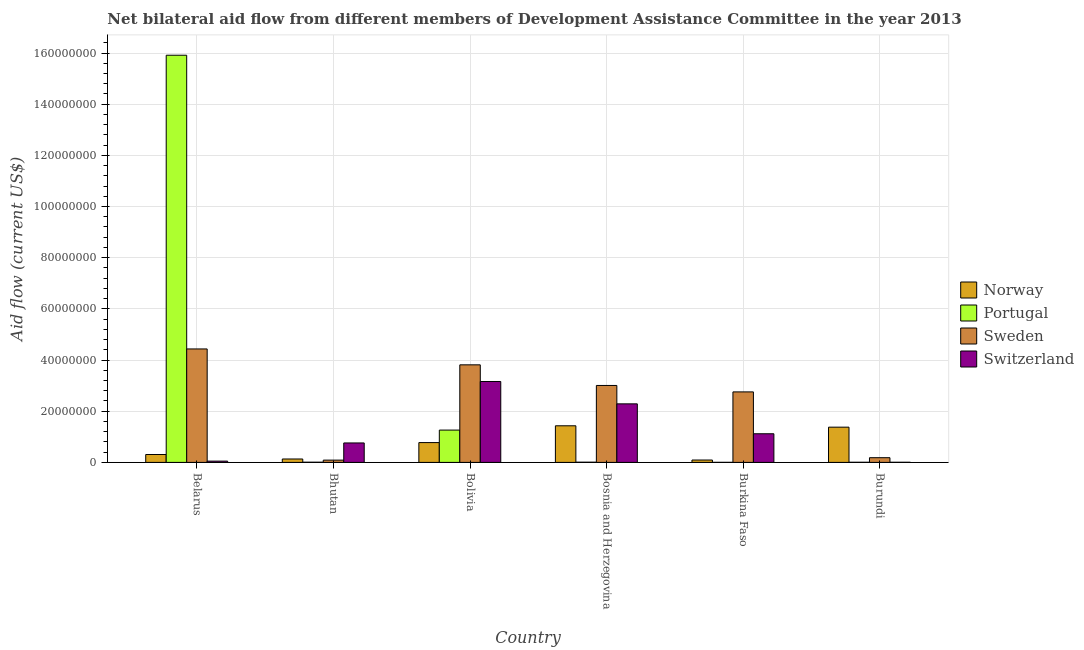How many different coloured bars are there?
Ensure brevity in your answer.  4. Are the number of bars on each tick of the X-axis equal?
Provide a succinct answer. Yes. What is the label of the 2nd group of bars from the left?
Your response must be concise. Bhutan. In how many cases, is the number of bars for a given country not equal to the number of legend labels?
Offer a very short reply. 0. What is the amount of aid given by norway in Burundi?
Make the answer very short. 1.38e+07. Across all countries, what is the maximum amount of aid given by norway?
Your answer should be very brief. 1.43e+07. Across all countries, what is the minimum amount of aid given by switzerland?
Keep it short and to the point. 5.00e+04. In which country was the amount of aid given by switzerland maximum?
Keep it short and to the point. Bolivia. In which country was the amount of aid given by portugal minimum?
Offer a very short reply. Burkina Faso. What is the total amount of aid given by norway in the graph?
Make the answer very short. 4.12e+07. What is the difference between the amount of aid given by norway in Bolivia and that in Burkina Faso?
Your response must be concise. 6.81e+06. What is the difference between the amount of aid given by switzerland in Bolivia and the amount of aid given by norway in Burundi?
Offer a very short reply. 1.78e+07. What is the average amount of aid given by norway per country?
Your answer should be very brief. 6.86e+06. What is the difference between the amount of aid given by switzerland and amount of aid given by portugal in Belarus?
Provide a succinct answer. -1.59e+08. In how many countries, is the amount of aid given by switzerland greater than 32000000 US$?
Make the answer very short. 0. What is the ratio of the amount of aid given by switzerland in Bosnia and Herzegovina to that in Burkina Faso?
Ensure brevity in your answer.  2.04. Is the difference between the amount of aid given by norway in Bhutan and Bosnia and Herzegovina greater than the difference between the amount of aid given by switzerland in Bhutan and Bosnia and Herzegovina?
Give a very brief answer. Yes. What is the difference between the highest and the second highest amount of aid given by norway?
Provide a succinct answer. 5.40e+05. What is the difference between the highest and the lowest amount of aid given by norway?
Ensure brevity in your answer.  1.34e+07. Is it the case that in every country, the sum of the amount of aid given by norway and amount of aid given by switzerland is greater than the sum of amount of aid given by portugal and amount of aid given by sweden?
Keep it short and to the point. No. What does the 3rd bar from the left in Burkina Faso represents?
Give a very brief answer. Sweden. What does the 1st bar from the right in Bolivia represents?
Give a very brief answer. Switzerland. How many bars are there?
Provide a succinct answer. 24. How many countries are there in the graph?
Give a very brief answer. 6. Are the values on the major ticks of Y-axis written in scientific E-notation?
Ensure brevity in your answer.  No. Does the graph contain grids?
Provide a short and direct response. Yes. Where does the legend appear in the graph?
Your response must be concise. Center right. What is the title of the graph?
Offer a terse response. Net bilateral aid flow from different members of Development Assistance Committee in the year 2013. Does "Third 20% of population" appear as one of the legend labels in the graph?
Ensure brevity in your answer.  No. What is the label or title of the X-axis?
Give a very brief answer. Country. What is the Aid flow (current US$) of Norway in Belarus?
Offer a terse response. 3.08e+06. What is the Aid flow (current US$) of Portugal in Belarus?
Offer a very short reply. 1.59e+08. What is the Aid flow (current US$) of Sweden in Belarus?
Give a very brief answer. 4.43e+07. What is the Aid flow (current US$) in Norway in Bhutan?
Offer a terse response. 1.33e+06. What is the Aid flow (current US$) of Sweden in Bhutan?
Your response must be concise. 8.90e+05. What is the Aid flow (current US$) of Switzerland in Bhutan?
Make the answer very short. 7.60e+06. What is the Aid flow (current US$) of Norway in Bolivia?
Your response must be concise. 7.74e+06. What is the Aid flow (current US$) of Portugal in Bolivia?
Keep it short and to the point. 1.26e+07. What is the Aid flow (current US$) in Sweden in Bolivia?
Offer a very short reply. 3.81e+07. What is the Aid flow (current US$) of Switzerland in Bolivia?
Your response must be concise. 3.16e+07. What is the Aid flow (current US$) in Norway in Bosnia and Herzegovina?
Provide a short and direct response. 1.43e+07. What is the Aid flow (current US$) in Portugal in Bosnia and Herzegovina?
Your answer should be compact. 8.00e+04. What is the Aid flow (current US$) of Sweden in Bosnia and Herzegovina?
Keep it short and to the point. 3.01e+07. What is the Aid flow (current US$) of Switzerland in Bosnia and Herzegovina?
Ensure brevity in your answer.  2.29e+07. What is the Aid flow (current US$) of Norway in Burkina Faso?
Offer a terse response. 9.30e+05. What is the Aid flow (current US$) in Portugal in Burkina Faso?
Your answer should be very brief. 2.00e+04. What is the Aid flow (current US$) of Sweden in Burkina Faso?
Offer a terse response. 2.76e+07. What is the Aid flow (current US$) of Switzerland in Burkina Faso?
Your answer should be compact. 1.12e+07. What is the Aid flow (current US$) in Norway in Burundi?
Provide a succinct answer. 1.38e+07. What is the Aid flow (current US$) of Sweden in Burundi?
Provide a short and direct response. 1.84e+06. Across all countries, what is the maximum Aid flow (current US$) of Norway?
Give a very brief answer. 1.43e+07. Across all countries, what is the maximum Aid flow (current US$) in Portugal?
Give a very brief answer. 1.59e+08. Across all countries, what is the maximum Aid flow (current US$) in Sweden?
Your response must be concise. 4.43e+07. Across all countries, what is the maximum Aid flow (current US$) in Switzerland?
Offer a terse response. 3.16e+07. Across all countries, what is the minimum Aid flow (current US$) in Norway?
Offer a very short reply. 9.30e+05. Across all countries, what is the minimum Aid flow (current US$) of Sweden?
Provide a succinct answer. 8.90e+05. What is the total Aid flow (current US$) in Norway in the graph?
Your response must be concise. 4.12e+07. What is the total Aid flow (current US$) of Portugal in the graph?
Offer a terse response. 1.72e+08. What is the total Aid flow (current US$) in Sweden in the graph?
Your answer should be very brief. 1.43e+08. What is the total Aid flow (current US$) in Switzerland in the graph?
Your answer should be compact. 7.38e+07. What is the difference between the Aid flow (current US$) of Norway in Belarus and that in Bhutan?
Your answer should be very brief. 1.75e+06. What is the difference between the Aid flow (current US$) in Portugal in Belarus and that in Bhutan?
Your answer should be compact. 1.59e+08. What is the difference between the Aid flow (current US$) in Sweden in Belarus and that in Bhutan?
Give a very brief answer. 4.34e+07. What is the difference between the Aid flow (current US$) in Switzerland in Belarus and that in Bhutan?
Ensure brevity in your answer.  -7.10e+06. What is the difference between the Aid flow (current US$) in Norway in Belarus and that in Bolivia?
Offer a terse response. -4.66e+06. What is the difference between the Aid flow (current US$) in Portugal in Belarus and that in Bolivia?
Provide a succinct answer. 1.46e+08. What is the difference between the Aid flow (current US$) of Sweden in Belarus and that in Bolivia?
Provide a succinct answer. 6.21e+06. What is the difference between the Aid flow (current US$) in Switzerland in Belarus and that in Bolivia?
Your response must be concise. -3.11e+07. What is the difference between the Aid flow (current US$) of Norway in Belarus and that in Bosnia and Herzegovina?
Make the answer very short. -1.12e+07. What is the difference between the Aid flow (current US$) of Portugal in Belarus and that in Bosnia and Herzegovina?
Offer a terse response. 1.59e+08. What is the difference between the Aid flow (current US$) of Sweden in Belarus and that in Bosnia and Herzegovina?
Your answer should be compact. 1.43e+07. What is the difference between the Aid flow (current US$) of Switzerland in Belarus and that in Bosnia and Herzegovina?
Provide a succinct answer. -2.24e+07. What is the difference between the Aid flow (current US$) in Norway in Belarus and that in Burkina Faso?
Your answer should be very brief. 2.15e+06. What is the difference between the Aid flow (current US$) of Portugal in Belarus and that in Burkina Faso?
Provide a short and direct response. 1.59e+08. What is the difference between the Aid flow (current US$) of Sweden in Belarus and that in Burkina Faso?
Offer a terse response. 1.68e+07. What is the difference between the Aid flow (current US$) in Switzerland in Belarus and that in Burkina Faso?
Make the answer very short. -1.07e+07. What is the difference between the Aid flow (current US$) in Norway in Belarus and that in Burundi?
Your answer should be very brief. -1.07e+07. What is the difference between the Aid flow (current US$) of Portugal in Belarus and that in Burundi?
Provide a succinct answer. 1.59e+08. What is the difference between the Aid flow (current US$) in Sweden in Belarus and that in Burundi?
Make the answer very short. 4.25e+07. What is the difference between the Aid flow (current US$) in Norway in Bhutan and that in Bolivia?
Offer a very short reply. -6.41e+06. What is the difference between the Aid flow (current US$) of Portugal in Bhutan and that in Bolivia?
Your answer should be compact. -1.26e+07. What is the difference between the Aid flow (current US$) of Sweden in Bhutan and that in Bolivia?
Your answer should be compact. -3.72e+07. What is the difference between the Aid flow (current US$) in Switzerland in Bhutan and that in Bolivia?
Provide a succinct answer. -2.40e+07. What is the difference between the Aid flow (current US$) in Norway in Bhutan and that in Bosnia and Herzegovina?
Ensure brevity in your answer.  -1.30e+07. What is the difference between the Aid flow (current US$) of Portugal in Bhutan and that in Bosnia and Herzegovina?
Provide a succinct answer. -10000. What is the difference between the Aid flow (current US$) in Sweden in Bhutan and that in Bosnia and Herzegovina?
Give a very brief answer. -2.92e+07. What is the difference between the Aid flow (current US$) of Switzerland in Bhutan and that in Bosnia and Herzegovina?
Keep it short and to the point. -1.53e+07. What is the difference between the Aid flow (current US$) of Norway in Bhutan and that in Burkina Faso?
Your response must be concise. 4.00e+05. What is the difference between the Aid flow (current US$) of Sweden in Bhutan and that in Burkina Faso?
Provide a succinct answer. -2.67e+07. What is the difference between the Aid flow (current US$) in Switzerland in Bhutan and that in Burkina Faso?
Your response must be concise. -3.59e+06. What is the difference between the Aid flow (current US$) of Norway in Bhutan and that in Burundi?
Offer a terse response. -1.24e+07. What is the difference between the Aid flow (current US$) of Sweden in Bhutan and that in Burundi?
Offer a terse response. -9.50e+05. What is the difference between the Aid flow (current US$) of Switzerland in Bhutan and that in Burundi?
Your response must be concise. 7.55e+06. What is the difference between the Aid flow (current US$) of Norway in Bolivia and that in Bosnia and Herzegovina?
Your answer should be very brief. -6.57e+06. What is the difference between the Aid flow (current US$) of Portugal in Bolivia and that in Bosnia and Herzegovina?
Your answer should be compact. 1.26e+07. What is the difference between the Aid flow (current US$) in Sweden in Bolivia and that in Bosnia and Herzegovina?
Your answer should be very brief. 8.06e+06. What is the difference between the Aid flow (current US$) of Switzerland in Bolivia and that in Bosnia and Herzegovina?
Give a very brief answer. 8.74e+06. What is the difference between the Aid flow (current US$) of Norway in Bolivia and that in Burkina Faso?
Keep it short and to the point. 6.81e+06. What is the difference between the Aid flow (current US$) of Portugal in Bolivia and that in Burkina Faso?
Offer a very short reply. 1.26e+07. What is the difference between the Aid flow (current US$) in Sweden in Bolivia and that in Burkina Faso?
Offer a very short reply. 1.06e+07. What is the difference between the Aid flow (current US$) in Switzerland in Bolivia and that in Burkina Faso?
Your answer should be compact. 2.04e+07. What is the difference between the Aid flow (current US$) of Norway in Bolivia and that in Burundi?
Provide a succinct answer. -6.03e+06. What is the difference between the Aid flow (current US$) in Portugal in Bolivia and that in Burundi?
Make the answer very short. 1.26e+07. What is the difference between the Aid flow (current US$) in Sweden in Bolivia and that in Burundi?
Your answer should be very brief. 3.63e+07. What is the difference between the Aid flow (current US$) in Switzerland in Bolivia and that in Burundi?
Ensure brevity in your answer.  3.16e+07. What is the difference between the Aid flow (current US$) of Norway in Bosnia and Herzegovina and that in Burkina Faso?
Provide a short and direct response. 1.34e+07. What is the difference between the Aid flow (current US$) of Portugal in Bosnia and Herzegovina and that in Burkina Faso?
Your answer should be very brief. 6.00e+04. What is the difference between the Aid flow (current US$) in Sweden in Bosnia and Herzegovina and that in Burkina Faso?
Ensure brevity in your answer.  2.52e+06. What is the difference between the Aid flow (current US$) of Switzerland in Bosnia and Herzegovina and that in Burkina Faso?
Your response must be concise. 1.17e+07. What is the difference between the Aid flow (current US$) of Norway in Bosnia and Herzegovina and that in Burundi?
Offer a very short reply. 5.40e+05. What is the difference between the Aid flow (current US$) of Portugal in Bosnia and Herzegovina and that in Burundi?
Offer a very short reply. 3.00e+04. What is the difference between the Aid flow (current US$) of Sweden in Bosnia and Herzegovina and that in Burundi?
Your answer should be compact. 2.82e+07. What is the difference between the Aid flow (current US$) of Switzerland in Bosnia and Herzegovina and that in Burundi?
Your answer should be very brief. 2.28e+07. What is the difference between the Aid flow (current US$) of Norway in Burkina Faso and that in Burundi?
Your answer should be very brief. -1.28e+07. What is the difference between the Aid flow (current US$) in Sweden in Burkina Faso and that in Burundi?
Provide a short and direct response. 2.57e+07. What is the difference between the Aid flow (current US$) in Switzerland in Burkina Faso and that in Burundi?
Make the answer very short. 1.11e+07. What is the difference between the Aid flow (current US$) of Norway in Belarus and the Aid flow (current US$) of Portugal in Bhutan?
Ensure brevity in your answer.  3.01e+06. What is the difference between the Aid flow (current US$) of Norway in Belarus and the Aid flow (current US$) of Sweden in Bhutan?
Give a very brief answer. 2.19e+06. What is the difference between the Aid flow (current US$) in Norway in Belarus and the Aid flow (current US$) in Switzerland in Bhutan?
Your answer should be very brief. -4.52e+06. What is the difference between the Aid flow (current US$) in Portugal in Belarus and the Aid flow (current US$) in Sweden in Bhutan?
Offer a very short reply. 1.58e+08. What is the difference between the Aid flow (current US$) of Portugal in Belarus and the Aid flow (current US$) of Switzerland in Bhutan?
Provide a succinct answer. 1.52e+08. What is the difference between the Aid flow (current US$) in Sweden in Belarus and the Aid flow (current US$) in Switzerland in Bhutan?
Offer a terse response. 3.67e+07. What is the difference between the Aid flow (current US$) in Norway in Belarus and the Aid flow (current US$) in Portugal in Bolivia?
Your answer should be very brief. -9.55e+06. What is the difference between the Aid flow (current US$) of Norway in Belarus and the Aid flow (current US$) of Sweden in Bolivia?
Your answer should be very brief. -3.50e+07. What is the difference between the Aid flow (current US$) in Norway in Belarus and the Aid flow (current US$) in Switzerland in Bolivia?
Your answer should be compact. -2.85e+07. What is the difference between the Aid flow (current US$) of Portugal in Belarus and the Aid flow (current US$) of Sweden in Bolivia?
Give a very brief answer. 1.21e+08. What is the difference between the Aid flow (current US$) in Portugal in Belarus and the Aid flow (current US$) in Switzerland in Bolivia?
Give a very brief answer. 1.28e+08. What is the difference between the Aid flow (current US$) in Sweden in Belarus and the Aid flow (current US$) in Switzerland in Bolivia?
Your answer should be very brief. 1.27e+07. What is the difference between the Aid flow (current US$) in Norway in Belarus and the Aid flow (current US$) in Sweden in Bosnia and Herzegovina?
Your answer should be compact. -2.70e+07. What is the difference between the Aid flow (current US$) in Norway in Belarus and the Aid flow (current US$) in Switzerland in Bosnia and Herzegovina?
Your response must be concise. -1.98e+07. What is the difference between the Aid flow (current US$) of Portugal in Belarus and the Aid flow (current US$) of Sweden in Bosnia and Herzegovina?
Ensure brevity in your answer.  1.29e+08. What is the difference between the Aid flow (current US$) in Portugal in Belarus and the Aid flow (current US$) in Switzerland in Bosnia and Herzegovina?
Your response must be concise. 1.36e+08. What is the difference between the Aid flow (current US$) in Sweden in Belarus and the Aid flow (current US$) in Switzerland in Bosnia and Herzegovina?
Ensure brevity in your answer.  2.15e+07. What is the difference between the Aid flow (current US$) in Norway in Belarus and the Aid flow (current US$) in Portugal in Burkina Faso?
Your response must be concise. 3.06e+06. What is the difference between the Aid flow (current US$) in Norway in Belarus and the Aid flow (current US$) in Sweden in Burkina Faso?
Make the answer very short. -2.45e+07. What is the difference between the Aid flow (current US$) of Norway in Belarus and the Aid flow (current US$) of Switzerland in Burkina Faso?
Provide a short and direct response. -8.11e+06. What is the difference between the Aid flow (current US$) of Portugal in Belarus and the Aid flow (current US$) of Sweden in Burkina Faso?
Offer a terse response. 1.32e+08. What is the difference between the Aid flow (current US$) in Portugal in Belarus and the Aid flow (current US$) in Switzerland in Burkina Faso?
Make the answer very short. 1.48e+08. What is the difference between the Aid flow (current US$) in Sweden in Belarus and the Aid flow (current US$) in Switzerland in Burkina Faso?
Offer a very short reply. 3.32e+07. What is the difference between the Aid flow (current US$) in Norway in Belarus and the Aid flow (current US$) in Portugal in Burundi?
Your answer should be compact. 3.03e+06. What is the difference between the Aid flow (current US$) of Norway in Belarus and the Aid flow (current US$) of Sweden in Burundi?
Offer a terse response. 1.24e+06. What is the difference between the Aid flow (current US$) of Norway in Belarus and the Aid flow (current US$) of Switzerland in Burundi?
Your response must be concise. 3.03e+06. What is the difference between the Aid flow (current US$) of Portugal in Belarus and the Aid flow (current US$) of Sweden in Burundi?
Give a very brief answer. 1.57e+08. What is the difference between the Aid flow (current US$) in Portugal in Belarus and the Aid flow (current US$) in Switzerland in Burundi?
Give a very brief answer. 1.59e+08. What is the difference between the Aid flow (current US$) in Sweden in Belarus and the Aid flow (current US$) in Switzerland in Burundi?
Provide a short and direct response. 4.43e+07. What is the difference between the Aid flow (current US$) in Norway in Bhutan and the Aid flow (current US$) in Portugal in Bolivia?
Offer a very short reply. -1.13e+07. What is the difference between the Aid flow (current US$) in Norway in Bhutan and the Aid flow (current US$) in Sweden in Bolivia?
Offer a terse response. -3.68e+07. What is the difference between the Aid flow (current US$) of Norway in Bhutan and the Aid flow (current US$) of Switzerland in Bolivia?
Provide a short and direct response. -3.03e+07. What is the difference between the Aid flow (current US$) of Portugal in Bhutan and the Aid flow (current US$) of Sweden in Bolivia?
Keep it short and to the point. -3.81e+07. What is the difference between the Aid flow (current US$) of Portugal in Bhutan and the Aid flow (current US$) of Switzerland in Bolivia?
Make the answer very short. -3.16e+07. What is the difference between the Aid flow (current US$) of Sweden in Bhutan and the Aid flow (current US$) of Switzerland in Bolivia?
Make the answer very short. -3.07e+07. What is the difference between the Aid flow (current US$) in Norway in Bhutan and the Aid flow (current US$) in Portugal in Bosnia and Herzegovina?
Your answer should be compact. 1.25e+06. What is the difference between the Aid flow (current US$) in Norway in Bhutan and the Aid flow (current US$) in Sweden in Bosnia and Herzegovina?
Ensure brevity in your answer.  -2.87e+07. What is the difference between the Aid flow (current US$) in Norway in Bhutan and the Aid flow (current US$) in Switzerland in Bosnia and Herzegovina?
Offer a terse response. -2.16e+07. What is the difference between the Aid flow (current US$) of Portugal in Bhutan and the Aid flow (current US$) of Sweden in Bosnia and Herzegovina?
Provide a short and direct response. -3.00e+07. What is the difference between the Aid flow (current US$) in Portugal in Bhutan and the Aid flow (current US$) in Switzerland in Bosnia and Herzegovina?
Offer a very short reply. -2.28e+07. What is the difference between the Aid flow (current US$) of Sweden in Bhutan and the Aid flow (current US$) of Switzerland in Bosnia and Herzegovina?
Offer a terse response. -2.20e+07. What is the difference between the Aid flow (current US$) in Norway in Bhutan and the Aid flow (current US$) in Portugal in Burkina Faso?
Provide a succinct answer. 1.31e+06. What is the difference between the Aid flow (current US$) of Norway in Bhutan and the Aid flow (current US$) of Sweden in Burkina Faso?
Offer a terse response. -2.62e+07. What is the difference between the Aid flow (current US$) of Norway in Bhutan and the Aid flow (current US$) of Switzerland in Burkina Faso?
Your answer should be compact. -9.86e+06. What is the difference between the Aid flow (current US$) in Portugal in Bhutan and the Aid flow (current US$) in Sweden in Burkina Faso?
Your response must be concise. -2.75e+07. What is the difference between the Aid flow (current US$) in Portugal in Bhutan and the Aid flow (current US$) in Switzerland in Burkina Faso?
Your answer should be compact. -1.11e+07. What is the difference between the Aid flow (current US$) of Sweden in Bhutan and the Aid flow (current US$) of Switzerland in Burkina Faso?
Your answer should be compact. -1.03e+07. What is the difference between the Aid flow (current US$) of Norway in Bhutan and the Aid flow (current US$) of Portugal in Burundi?
Provide a short and direct response. 1.28e+06. What is the difference between the Aid flow (current US$) in Norway in Bhutan and the Aid flow (current US$) in Sweden in Burundi?
Make the answer very short. -5.10e+05. What is the difference between the Aid flow (current US$) in Norway in Bhutan and the Aid flow (current US$) in Switzerland in Burundi?
Provide a succinct answer. 1.28e+06. What is the difference between the Aid flow (current US$) of Portugal in Bhutan and the Aid flow (current US$) of Sweden in Burundi?
Provide a succinct answer. -1.77e+06. What is the difference between the Aid flow (current US$) of Sweden in Bhutan and the Aid flow (current US$) of Switzerland in Burundi?
Give a very brief answer. 8.40e+05. What is the difference between the Aid flow (current US$) of Norway in Bolivia and the Aid flow (current US$) of Portugal in Bosnia and Herzegovina?
Give a very brief answer. 7.66e+06. What is the difference between the Aid flow (current US$) in Norway in Bolivia and the Aid flow (current US$) in Sweden in Bosnia and Herzegovina?
Provide a short and direct response. -2.23e+07. What is the difference between the Aid flow (current US$) in Norway in Bolivia and the Aid flow (current US$) in Switzerland in Bosnia and Herzegovina?
Make the answer very short. -1.51e+07. What is the difference between the Aid flow (current US$) in Portugal in Bolivia and the Aid flow (current US$) in Sweden in Bosnia and Herzegovina?
Your answer should be compact. -1.74e+07. What is the difference between the Aid flow (current US$) in Portugal in Bolivia and the Aid flow (current US$) in Switzerland in Bosnia and Herzegovina?
Offer a terse response. -1.02e+07. What is the difference between the Aid flow (current US$) in Sweden in Bolivia and the Aid flow (current US$) in Switzerland in Bosnia and Herzegovina?
Your answer should be compact. 1.52e+07. What is the difference between the Aid flow (current US$) in Norway in Bolivia and the Aid flow (current US$) in Portugal in Burkina Faso?
Make the answer very short. 7.72e+06. What is the difference between the Aid flow (current US$) of Norway in Bolivia and the Aid flow (current US$) of Sweden in Burkina Faso?
Provide a succinct answer. -1.98e+07. What is the difference between the Aid flow (current US$) of Norway in Bolivia and the Aid flow (current US$) of Switzerland in Burkina Faso?
Provide a short and direct response. -3.45e+06. What is the difference between the Aid flow (current US$) of Portugal in Bolivia and the Aid flow (current US$) of Sweden in Burkina Faso?
Ensure brevity in your answer.  -1.49e+07. What is the difference between the Aid flow (current US$) in Portugal in Bolivia and the Aid flow (current US$) in Switzerland in Burkina Faso?
Your response must be concise. 1.44e+06. What is the difference between the Aid flow (current US$) in Sweden in Bolivia and the Aid flow (current US$) in Switzerland in Burkina Faso?
Offer a terse response. 2.69e+07. What is the difference between the Aid flow (current US$) of Norway in Bolivia and the Aid flow (current US$) of Portugal in Burundi?
Your response must be concise. 7.69e+06. What is the difference between the Aid flow (current US$) of Norway in Bolivia and the Aid flow (current US$) of Sweden in Burundi?
Your answer should be very brief. 5.90e+06. What is the difference between the Aid flow (current US$) in Norway in Bolivia and the Aid flow (current US$) in Switzerland in Burundi?
Provide a succinct answer. 7.69e+06. What is the difference between the Aid flow (current US$) of Portugal in Bolivia and the Aid flow (current US$) of Sweden in Burundi?
Provide a short and direct response. 1.08e+07. What is the difference between the Aid flow (current US$) in Portugal in Bolivia and the Aid flow (current US$) in Switzerland in Burundi?
Your answer should be very brief. 1.26e+07. What is the difference between the Aid flow (current US$) in Sweden in Bolivia and the Aid flow (current US$) in Switzerland in Burundi?
Offer a terse response. 3.81e+07. What is the difference between the Aid flow (current US$) of Norway in Bosnia and Herzegovina and the Aid flow (current US$) of Portugal in Burkina Faso?
Provide a succinct answer. 1.43e+07. What is the difference between the Aid flow (current US$) of Norway in Bosnia and Herzegovina and the Aid flow (current US$) of Sweden in Burkina Faso?
Provide a succinct answer. -1.32e+07. What is the difference between the Aid flow (current US$) in Norway in Bosnia and Herzegovina and the Aid flow (current US$) in Switzerland in Burkina Faso?
Offer a terse response. 3.12e+06. What is the difference between the Aid flow (current US$) of Portugal in Bosnia and Herzegovina and the Aid flow (current US$) of Sweden in Burkina Faso?
Keep it short and to the point. -2.75e+07. What is the difference between the Aid flow (current US$) of Portugal in Bosnia and Herzegovina and the Aid flow (current US$) of Switzerland in Burkina Faso?
Give a very brief answer. -1.11e+07. What is the difference between the Aid flow (current US$) of Sweden in Bosnia and Herzegovina and the Aid flow (current US$) of Switzerland in Burkina Faso?
Make the answer very short. 1.89e+07. What is the difference between the Aid flow (current US$) of Norway in Bosnia and Herzegovina and the Aid flow (current US$) of Portugal in Burundi?
Ensure brevity in your answer.  1.43e+07. What is the difference between the Aid flow (current US$) in Norway in Bosnia and Herzegovina and the Aid flow (current US$) in Sweden in Burundi?
Make the answer very short. 1.25e+07. What is the difference between the Aid flow (current US$) of Norway in Bosnia and Herzegovina and the Aid flow (current US$) of Switzerland in Burundi?
Make the answer very short. 1.43e+07. What is the difference between the Aid flow (current US$) in Portugal in Bosnia and Herzegovina and the Aid flow (current US$) in Sweden in Burundi?
Make the answer very short. -1.76e+06. What is the difference between the Aid flow (current US$) in Sweden in Bosnia and Herzegovina and the Aid flow (current US$) in Switzerland in Burundi?
Give a very brief answer. 3.00e+07. What is the difference between the Aid flow (current US$) of Norway in Burkina Faso and the Aid flow (current US$) of Portugal in Burundi?
Make the answer very short. 8.80e+05. What is the difference between the Aid flow (current US$) in Norway in Burkina Faso and the Aid flow (current US$) in Sweden in Burundi?
Offer a very short reply. -9.10e+05. What is the difference between the Aid flow (current US$) in Norway in Burkina Faso and the Aid flow (current US$) in Switzerland in Burundi?
Your answer should be very brief. 8.80e+05. What is the difference between the Aid flow (current US$) of Portugal in Burkina Faso and the Aid flow (current US$) of Sweden in Burundi?
Provide a short and direct response. -1.82e+06. What is the difference between the Aid flow (current US$) of Portugal in Burkina Faso and the Aid flow (current US$) of Switzerland in Burundi?
Provide a succinct answer. -3.00e+04. What is the difference between the Aid flow (current US$) in Sweden in Burkina Faso and the Aid flow (current US$) in Switzerland in Burundi?
Your answer should be very brief. 2.75e+07. What is the average Aid flow (current US$) of Norway per country?
Your answer should be very brief. 6.86e+06. What is the average Aid flow (current US$) of Portugal per country?
Ensure brevity in your answer.  2.87e+07. What is the average Aid flow (current US$) in Sweden per country?
Give a very brief answer. 2.38e+07. What is the average Aid flow (current US$) of Switzerland per country?
Provide a succinct answer. 1.23e+07. What is the difference between the Aid flow (current US$) in Norway and Aid flow (current US$) in Portugal in Belarus?
Provide a short and direct response. -1.56e+08. What is the difference between the Aid flow (current US$) in Norway and Aid flow (current US$) in Sweden in Belarus?
Provide a succinct answer. -4.13e+07. What is the difference between the Aid flow (current US$) of Norway and Aid flow (current US$) of Switzerland in Belarus?
Ensure brevity in your answer.  2.58e+06. What is the difference between the Aid flow (current US$) in Portugal and Aid flow (current US$) in Sweden in Belarus?
Offer a very short reply. 1.15e+08. What is the difference between the Aid flow (current US$) of Portugal and Aid flow (current US$) of Switzerland in Belarus?
Provide a succinct answer. 1.59e+08. What is the difference between the Aid flow (current US$) of Sweden and Aid flow (current US$) of Switzerland in Belarus?
Provide a short and direct response. 4.38e+07. What is the difference between the Aid flow (current US$) in Norway and Aid flow (current US$) in Portugal in Bhutan?
Offer a terse response. 1.26e+06. What is the difference between the Aid flow (current US$) of Norway and Aid flow (current US$) of Switzerland in Bhutan?
Offer a very short reply. -6.27e+06. What is the difference between the Aid flow (current US$) in Portugal and Aid flow (current US$) in Sweden in Bhutan?
Your answer should be very brief. -8.20e+05. What is the difference between the Aid flow (current US$) in Portugal and Aid flow (current US$) in Switzerland in Bhutan?
Provide a short and direct response. -7.53e+06. What is the difference between the Aid flow (current US$) of Sweden and Aid flow (current US$) of Switzerland in Bhutan?
Ensure brevity in your answer.  -6.71e+06. What is the difference between the Aid flow (current US$) in Norway and Aid flow (current US$) in Portugal in Bolivia?
Your response must be concise. -4.89e+06. What is the difference between the Aid flow (current US$) of Norway and Aid flow (current US$) of Sweden in Bolivia?
Provide a succinct answer. -3.04e+07. What is the difference between the Aid flow (current US$) of Norway and Aid flow (current US$) of Switzerland in Bolivia?
Provide a succinct answer. -2.39e+07. What is the difference between the Aid flow (current US$) of Portugal and Aid flow (current US$) of Sweden in Bolivia?
Give a very brief answer. -2.55e+07. What is the difference between the Aid flow (current US$) of Portugal and Aid flow (current US$) of Switzerland in Bolivia?
Ensure brevity in your answer.  -1.90e+07. What is the difference between the Aid flow (current US$) of Sweden and Aid flow (current US$) of Switzerland in Bolivia?
Provide a short and direct response. 6.51e+06. What is the difference between the Aid flow (current US$) in Norway and Aid flow (current US$) in Portugal in Bosnia and Herzegovina?
Your response must be concise. 1.42e+07. What is the difference between the Aid flow (current US$) in Norway and Aid flow (current US$) in Sweden in Bosnia and Herzegovina?
Ensure brevity in your answer.  -1.58e+07. What is the difference between the Aid flow (current US$) of Norway and Aid flow (current US$) of Switzerland in Bosnia and Herzegovina?
Give a very brief answer. -8.57e+06. What is the difference between the Aid flow (current US$) in Portugal and Aid flow (current US$) in Sweden in Bosnia and Herzegovina?
Make the answer very short. -3.00e+07. What is the difference between the Aid flow (current US$) in Portugal and Aid flow (current US$) in Switzerland in Bosnia and Herzegovina?
Offer a terse response. -2.28e+07. What is the difference between the Aid flow (current US$) of Sweden and Aid flow (current US$) of Switzerland in Bosnia and Herzegovina?
Your answer should be compact. 7.19e+06. What is the difference between the Aid flow (current US$) in Norway and Aid flow (current US$) in Portugal in Burkina Faso?
Keep it short and to the point. 9.10e+05. What is the difference between the Aid flow (current US$) in Norway and Aid flow (current US$) in Sweden in Burkina Faso?
Give a very brief answer. -2.66e+07. What is the difference between the Aid flow (current US$) of Norway and Aid flow (current US$) of Switzerland in Burkina Faso?
Offer a very short reply. -1.03e+07. What is the difference between the Aid flow (current US$) of Portugal and Aid flow (current US$) of Sweden in Burkina Faso?
Make the answer very short. -2.75e+07. What is the difference between the Aid flow (current US$) in Portugal and Aid flow (current US$) in Switzerland in Burkina Faso?
Your answer should be very brief. -1.12e+07. What is the difference between the Aid flow (current US$) of Sweden and Aid flow (current US$) of Switzerland in Burkina Faso?
Your answer should be compact. 1.64e+07. What is the difference between the Aid flow (current US$) of Norway and Aid flow (current US$) of Portugal in Burundi?
Keep it short and to the point. 1.37e+07. What is the difference between the Aid flow (current US$) of Norway and Aid flow (current US$) of Sweden in Burundi?
Your answer should be compact. 1.19e+07. What is the difference between the Aid flow (current US$) of Norway and Aid flow (current US$) of Switzerland in Burundi?
Your answer should be compact. 1.37e+07. What is the difference between the Aid flow (current US$) in Portugal and Aid flow (current US$) in Sweden in Burundi?
Your response must be concise. -1.79e+06. What is the difference between the Aid flow (current US$) in Sweden and Aid flow (current US$) in Switzerland in Burundi?
Offer a very short reply. 1.79e+06. What is the ratio of the Aid flow (current US$) in Norway in Belarus to that in Bhutan?
Give a very brief answer. 2.32. What is the ratio of the Aid flow (current US$) in Portugal in Belarus to that in Bhutan?
Your response must be concise. 2273.29. What is the ratio of the Aid flow (current US$) of Sweden in Belarus to that in Bhutan?
Provide a succinct answer. 49.82. What is the ratio of the Aid flow (current US$) in Switzerland in Belarus to that in Bhutan?
Ensure brevity in your answer.  0.07. What is the ratio of the Aid flow (current US$) of Norway in Belarus to that in Bolivia?
Offer a very short reply. 0.4. What is the ratio of the Aid flow (current US$) of Portugal in Belarus to that in Bolivia?
Offer a very short reply. 12.6. What is the ratio of the Aid flow (current US$) in Sweden in Belarus to that in Bolivia?
Offer a terse response. 1.16. What is the ratio of the Aid flow (current US$) in Switzerland in Belarus to that in Bolivia?
Keep it short and to the point. 0.02. What is the ratio of the Aid flow (current US$) of Norway in Belarus to that in Bosnia and Herzegovina?
Provide a succinct answer. 0.22. What is the ratio of the Aid flow (current US$) of Portugal in Belarus to that in Bosnia and Herzegovina?
Ensure brevity in your answer.  1989.12. What is the ratio of the Aid flow (current US$) of Sweden in Belarus to that in Bosnia and Herzegovina?
Offer a terse response. 1.47. What is the ratio of the Aid flow (current US$) of Switzerland in Belarus to that in Bosnia and Herzegovina?
Offer a very short reply. 0.02. What is the ratio of the Aid flow (current US$) of Norway in Belarus to that in Burkina Faso?
Your answer should be compact. 3.31. What is the ratio of the Aid flow (current US$) in Portugal in Belarus to that in Burkina Faso?
Your answer should be very brief. 7956.5. What is the ratio of the Aid flow (current US$) of Sweden in Belarus to that in Burkina Faso?
Provide a succinct answer. 1.61. What is the ratio of the Aid flow (current US$) in Switzerland in Belarus to that in Burkina Faso?
Provide a succinct answer. 0.04. What is the ratio of the Aid flow (current US$) of Norway in Belarus to that in Burundi?
Your answer should be very brief. 0.22. What is the ratio of the Aid flow (current US$) in Portugal in Belarus to that in Burundi?
Provide a succinct answer. 3182.6. What is the ratio of the Aid flow (current US$) in Sweden in Belarus to that in Burundi?
Your answer should be compact. 24.1. What is the ratio of the Aid flow (current US$) of Switzerland in Belarus to that in Burundi?
Your response must be concise. 10. What is the ratio of the Aid flow (current US$) in Norway in Bhutan to that in Bolivia?
Make the answer very short. 0.17. What is the ratio of the Aid flow (current US$) of Portugal in Bhutan to that in Bolivia?
Your answer should be very brief. 0.01. What is the ratio of the Aid flow (current US$) of Sweden in Bhutan to that in Bolivia?
Keep it short and to the point. 0.02. What is the ratio of the Aid flow (current US$) in Switzerland in Bhutan to that in Bolivia?
Keep it short and to the point. 0.24. What is the ratio of the Aid flow (current US$) of Norway in Bhutan to that in Bosnia and Herzegovina?
Provide a short and direct response. 0.09. What is the ratio of the Aid flow (current US$) in Sweden in Bhutan to that in Bosnia and Herzegovina?
Offer a terse response. 0.03. What is the ratio of the Aid flow (current US$) of Switzerland in Bhutan to that in Bosnia and Herzegovina?
Keep it short and to the point. 0.33. What is the ratio of the Aid flow (current US$) in Norway in Bhutan to that in Burkina Faso?
Your answer should be compact. 1.43. What is the ratio of the Aid flow (current US$) in Portugal in Bhutan to that in Burkina Faso?
Offer a very short reply. 3.5. What is the ratio of the Aid flow (current US$) in Sweden in Bhutan to that in Burkina Faso?
Give a very brief answer. 0.03. What is the ratio of the Aid flow (current US$) in Switzerland in Bhutan to that in Burkina Faso?
Your answer should be compact. 0.68. What is the ratio of the Aid flow (current US$) of Norway in Bhutan to that in Burundi?
Your response must be concise. 0.1. What is the ratio of the Aid flow (current US$) in Portugal in Bhutan to that in Burundi?
Ensure brevity in your answer.  1.4. What is the ratio of the Aid flow (current US$) in Sweden in Bhutan to that in Burundi?
Your answer should be very brief. 0.48. What is the ratio of the Aid flow (current US$) in Switzerland in Bhutan to that in Burundi?
Keep it short and to the point. 152. What is the ratio of the Aid flow (current US$) in Norway in Bolivia to that in Bosnia and Herzegovina?
Your answer should be compact. 0.54. What is the ratio of the Aid flow (current US$) of Portugal in Bolivia to that in Bosnia and Herzegovina?
Keep it short and to the point. 157.88. What is the ratio of the Aid flow (current US$) of Sweden in Bolivia to that in Bosnia and Herzegovina?
Ensure brevity in your answer.  1.27. What is the ratio of the Aid flow (current US$) in Switzerland in Bolivia to that in Bosnia and Herzegovina?
Make the answer very short. 1.38. What is the ratio of the Aid flow (current US$) in Norway in Bolivia to that in Burkina Faso?
Give a very brief answer. 8.32. What is the ratio of the Aid flow (current US$) of Portugal in Bolivia to that in Burkina Faso?
Your response must be concise. 631.5. What is the ratio of the Aid flow (current US$) of Sweden in Bolivia to that in Burkina Faso?
Offer a very short reply. 1.38. What is the ratio of the Aid flow (current US$) in Switzerland in Bolivia to that in Burkina Faso?
Ensure brevity in your answer.  2.83. What is the ratio of the Aid flow (current US$) of Norway in Bolivia to that in Burundi?
Ensure brevity in your answer.  0.56. What is the ratio of the Aid flow (current US$) in Portugal in Bolivia to that in Burundi?
Offer a terse response. 252.6. What is the ratio of the Aid flow (current US$) in Sweden in Bolivia to that in Burundi?
Give a very brief answer. 20.72. What is the ratio of the Aid flow (current US$) in Switzerland in Bolivia to that in Burundi?
Give a very brief answer. 632.4. What is the ratio of the Aid flow (current US$) of Norway in Bosnia and Herzegovina to that in Burkina Faso?
Ensure brevity in your answer.  15.39. What is the ratio of the Aid flow (current US$) in Portugal in Bosnia and Herzegovina to that in Burkina Faso?
Provide a succinct answer. 4. What is the ratio of the Aid flow (current US$) in Sweden in Bosnia and Herzegovina to that in Burkina Faso?
Offer a very short reply. 1.09. What is the ratio of the Aid flow (current US$) of Switzerland in Bosnia and Herzegovina to that in Burkina Faso?
Give a very brief answer. 2.04. What is the ratio of the Aid flow (current US$) in Norway in Bosnia and Herzegovina to that in Burundi?
Your response must be concise. 1.04. What is the ratio of the Aid flow (current US$) in Sweden in Bosnia and Herzegovina to that in Burundi?
Your answer should be very brief. 16.34. What is the ratio of the Aid flow (current US$) in Switzerland in Bosnia and Herzegovina to that in Burundi?
Your answer should be very brief. 457.6. What is the ratio of the Aid flow (current US$) of Norway in Burkina Faso to that in Burundi?
Offer a very short reply. 0.07. What is the ratio of the Aid flow (current US$) in Portugal in Burkina Faso to that in Burundi?
Keep it short and to the point. 0.4. What is the ratio of the Aid flow (current US$) of Sweden in Burkina Faso to that in Burundi?
Give a very brief answer. 14.97. What is the ratio of the Aid flow (current US$) of Switzerland in Burkina Faso to that in Burundi?
Offer a terse response. 223.8. What is the difference between the highest and the second highest Aid flow (current US$) in Norway?
Provide a short and direct response. 5.40e+05. What is the difference between the highest and the second highest Aid flow (current US$) in Portugal?
Offer a very short reply. 1.46e+08. What is the difference between the highest and the second highest Aid flow (current US$) of Sweden?
Your response must be concise. 6.21e+06. What is the difference between the highest and the second highest Aid flow (current US$) in Switzerland?
Provide a short and direct response. 8.74e+06. What is the difference between the highest and the lowest Aid flow (current US$) in Norway?
Your answer should be very brief. 1.34e+07. What is the difference between the highest and the lowest Aid flow (current US$) in Portugal?
Keep it short and to the point. 1.59e+08. What is the difference between the highest and the lowest Aid flow (current US$) in Sweden?
Provide a short and direct response. 4.34e+07. What is the difference between the highest and the lowest Aid flow (current US$) in Switzerland?
Give a very brief answer. 3.16e+07. 